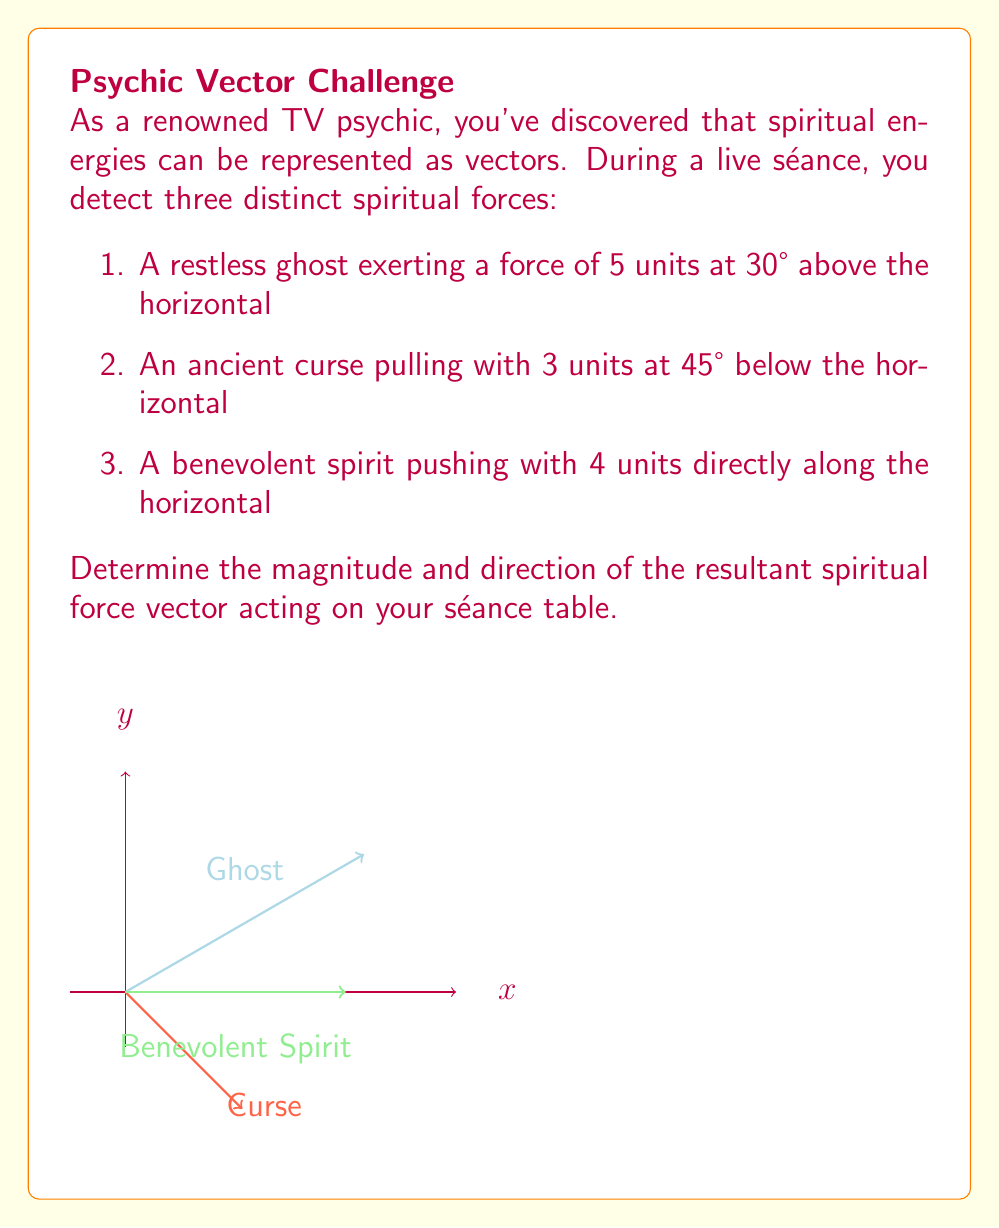Teach me how to tackle this problem. Let's approach this problem step-by-step using vector addition:

1) First, let's break down each force into its x and y components:

   Ghost: $F_1 = 5 \angle 30°$
   $F_{1x} = 5 \cos 30° = 5 \cdot \frac{\sqrt{3}}{2} = 2.5\sqrt{3}$
   $F_{1y} = 5 \sin 30° = 5 \cdot \frac{1}{2} = 2.5$

   Curse: $F_2 = 3 \angle -45°$
   $F_{2x} = 3 \cos (-45°) = 3 \cdot \frac{\sqrt{2}}{2} = 1.5\sqrt{2}$
   $F_{2y} = 3 \sin (-45°) = -3 \cdot \frac{\sqrt{2}}{2} = -1.5\sqrt{2}$

   Benevolent Spirit: $F_3 = 4 \angle 0°$
   $F_{3x} = 4$
   $F_{3y} = 0$

2) Now, sum up all the x-components and y-components:

   $F_x = F_{1x} + F_{2x} + F_{3x} = 2.5\sqrt{3} + 1.5\sqrt{2} + 4$
   $F_y = F_{1y} + F_{2y} + F_{3y} = 2.5 - 1.5\sqrt{2} + 0 = 2.5 - 1.5\sqrt{2}$

3) The magnitude of the resultant force can be calculated using the Pythagorean theorem:

   $F = \sqrt{F_x^2 + F_y^2} = \sqrt{(2.5\sqrt{3} + 1.5\sqrt{2} + 4)^2 + (2.5 - 1.5\sqrt{2})^2}$

4) The direction of the resultant force can be found using the arctangent function:

   $\theta = \tan^{-1}(\frac{F_y}{F_x}) = \tan^{-1}(\frac{2.5 - 1.5\sqrt{2}}{2.5\sqrt{3} + 1.5\sqrt{2} + 4})$

5) Simplifying and calculating:

   $F \approx 7.28$ units
   $\theta \approx 11.31°$

Therefore, the resultant spiritual force has a magnitude of approximately 7.28 units and acts at an angle of about 11.31° above the horizontal.
Answer: $$7.28 \text{ units at } 11.31° \text{ above horizontal}$$ 